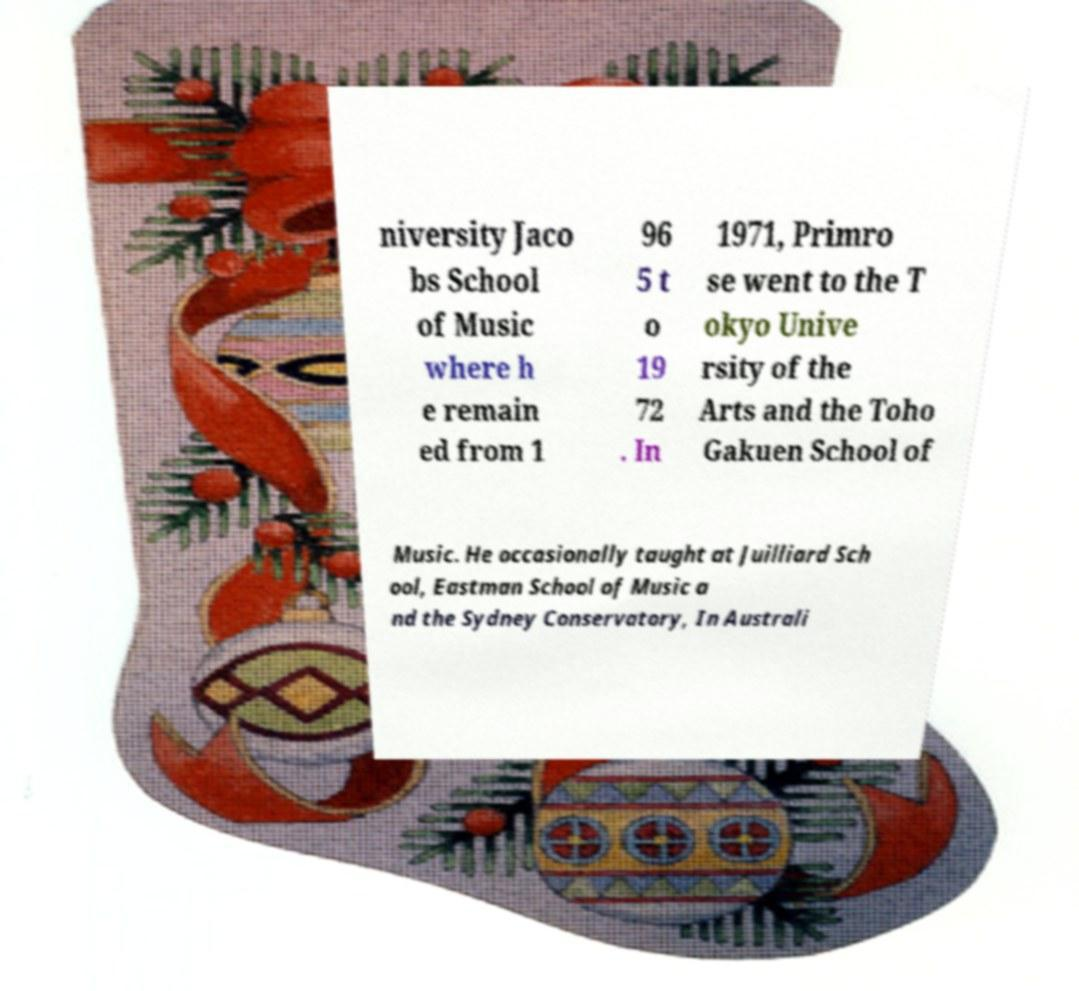I need the written content from this picture converted into text. Can you do that? niversity Jaco bs School of Music where h e remain ed from 1 96 5 t o 19 72 . In 1971, Primro se went to the T okyo Unive rsity of the Arts and the Toho Gakuen School of Music. He occasionally taught at Juilliard Sch ool, Eastman School of Music a nd the Sydney Conservatory, In Australi 